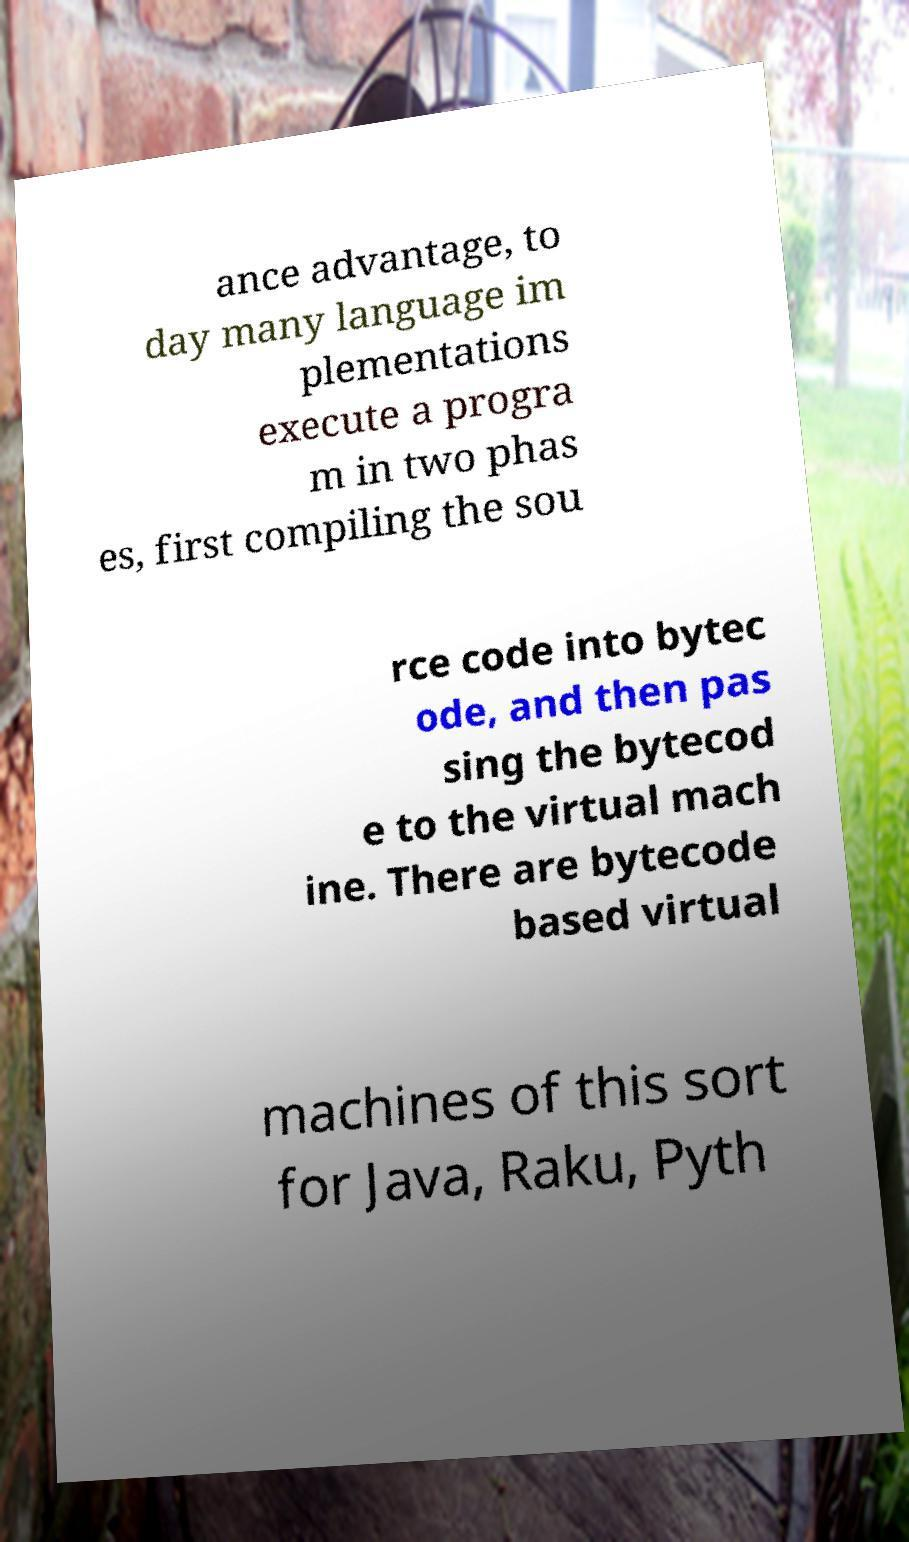Please identify and transcribe the text found in this image. ance advantage, to day many language im plementations execute a progra m in two phas es, first compiling the sou rce code into bytec ode, and then pas sing the bytecod e to the virtual mach ine. There are bytecode based virtual machines of this sort for Java, Raku, Pyth 